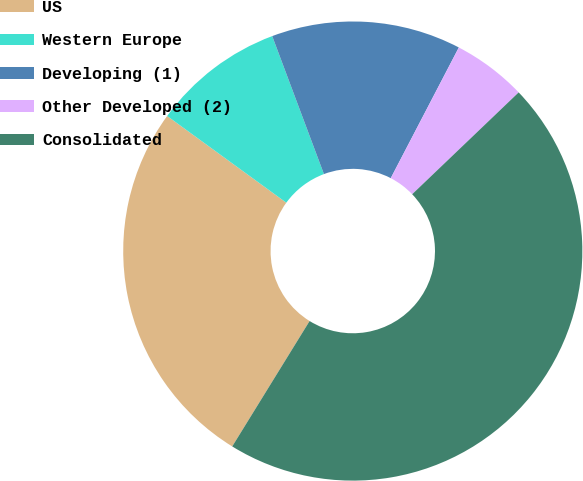Convert chart. <chart><loc_0><loc_0><loc_500><loc_500><pie_chart><fcel>US<fcel>Western Europe<fcel>Developing (1)<fcel>Other Developed (2)<fcel>Consolidated<nl><fcel>26.21%<fcel>9.28%<fcel>13.35%<fcel>5.21%<fcel>45.94%<nl></chart> 